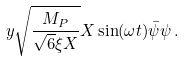Convert formula to latex. <formula><loc_0><loc_0><loc_500><loc_500>y \sqrt { \frac { M _ { P } } { \sqrt { 6 } \xi X } } X \sin ( \omega t ) \bar { \psi } \psi \, .</formula> 